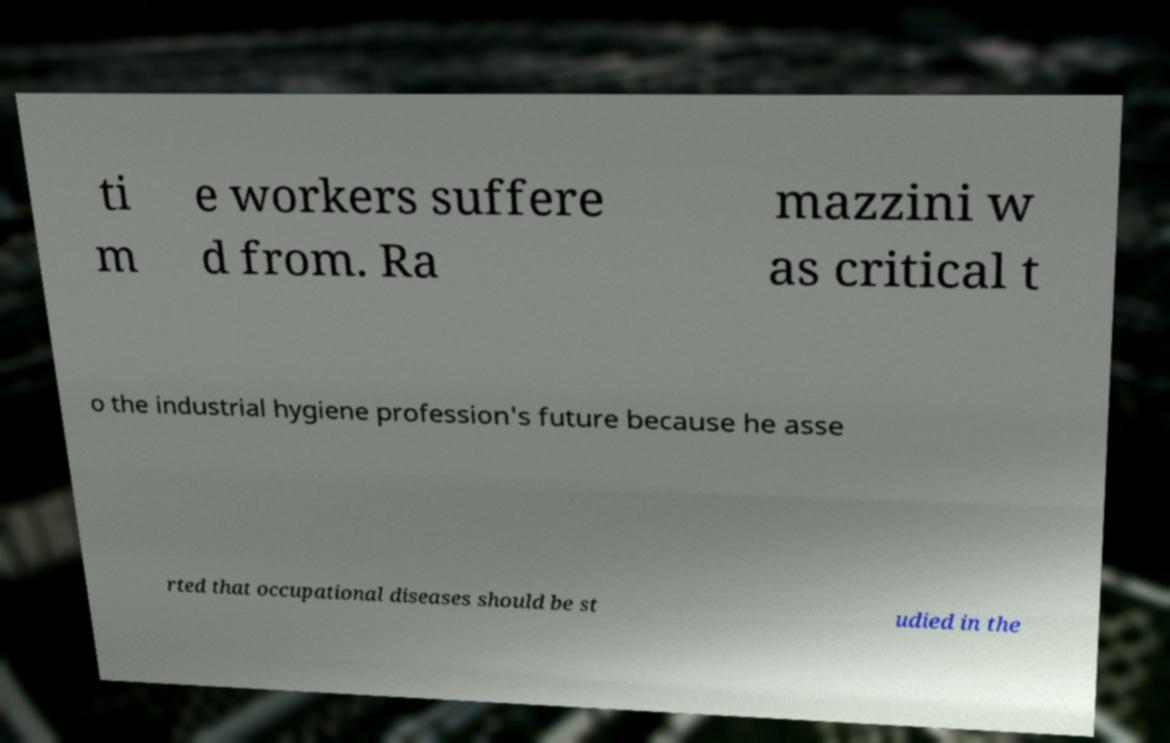Could you assist in decoding the text presented in this image and type it out clearly? ti m e workers suffere d from. Ra mazzini w as critical t o the industrial hygiene profession's future because he asse rted that occupational diseases should be st udied in the 